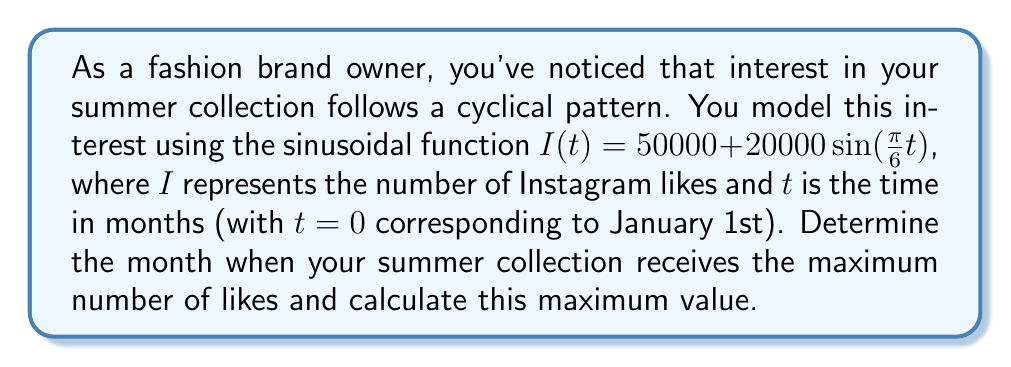Could you help me with this problem? To solve this problem, we need to analyze the given sinusoidal function:

$I(t) = 50000 + 20000\sin(\frac{\pi}{6}t)$

1) First, let's identify the components of this function:
   - Midline (average value): 50000
   - Amplitude: 20000
   - Period: $\frac{2\pi}{\frac{\pi}{6}} = 12$ months (which makes sense for an annual cycle)

2) The maximum value occurs when $\sin(\frac{\pi}{6}t)$ is at its peak, which is 1.

3) To find when this happens, we solve:

   $\frac{\pi}{6}t = \frac{\pi}{2}$ (since sine reaches its maximum at $\frac{\pi}{2}$)

4) Solving for $t$:
   
   $t = \frac{\pi}{2} \cdot \frac{6}{\pi} = 3$

5) This means the maximum occurs 3 months after January 1st, which is April 1st.

6) To calculate the maximum value:

   $I_{max} = 50000 + 20000 \cdot 1 = 70000$

Therefore, the summer collection receives the maximum number of likes (70,000) on April 1st.
Answer: The summer collection receives the maximum number of likes on April 1st, with 70,000 likes. 